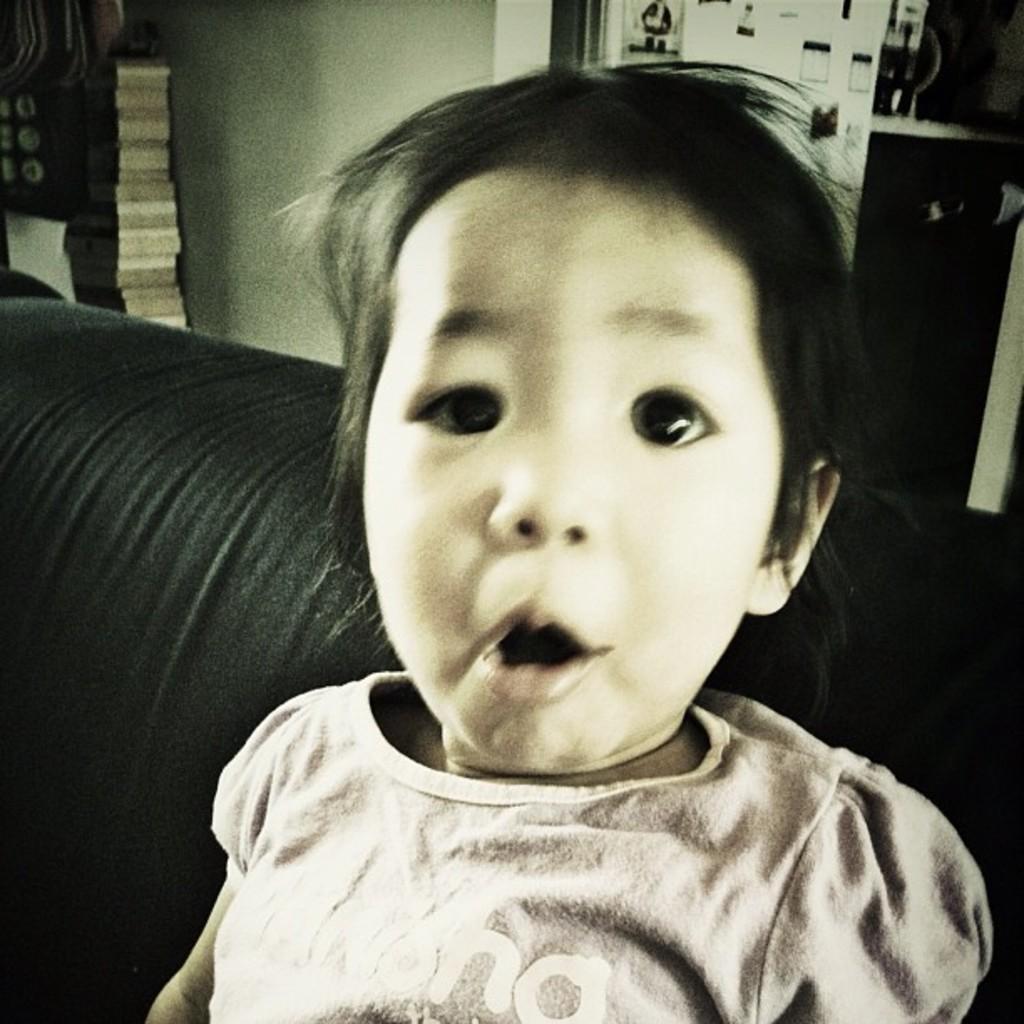Can you describe this image briefly? In this image I can see a child. In the background I can see a wall and some other objects. 